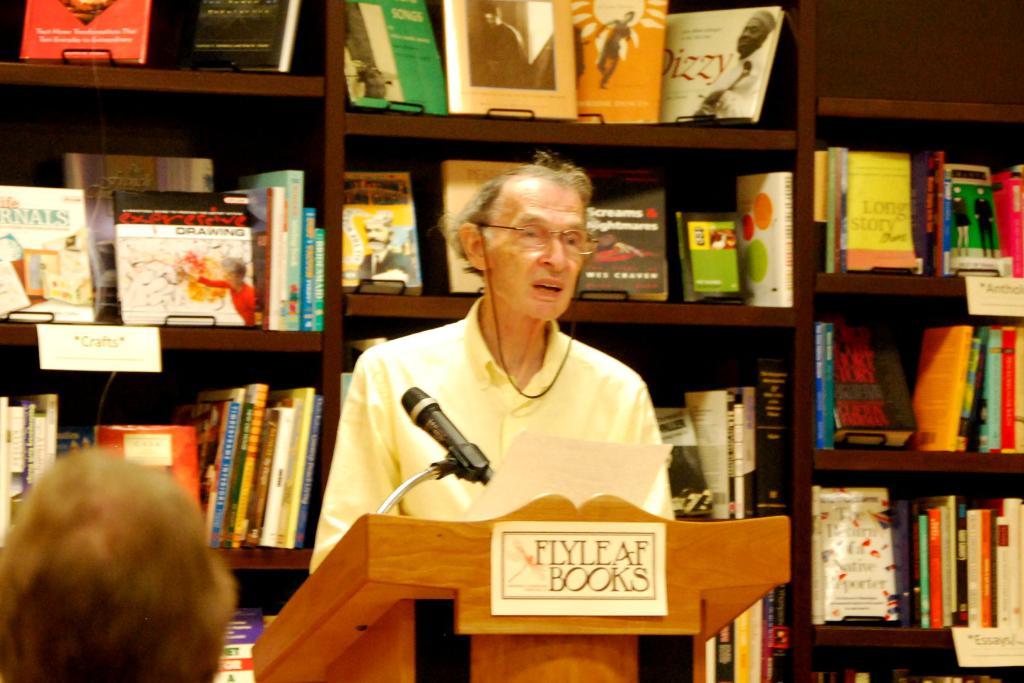What is written at the front of the stand?
Your answer should be very brief. Flyleaf books. What types of books are advertised on the alter?
Give a very brief answer. Flyleaf. 